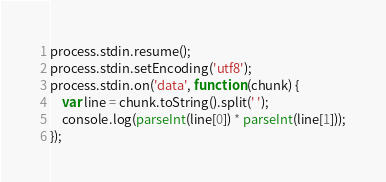<code> <loc_0><loc_0><loc_500><loc_500><_JavaScript_>process.stdin.resume();
process.stdin.setEncoding('utf8');
process.stdin.on('data', function (chunk) {
    var line = chunk.toString().split(' ');
    console.log(parseInt(line[0]) * parseInt(line[1]));
});</code> 